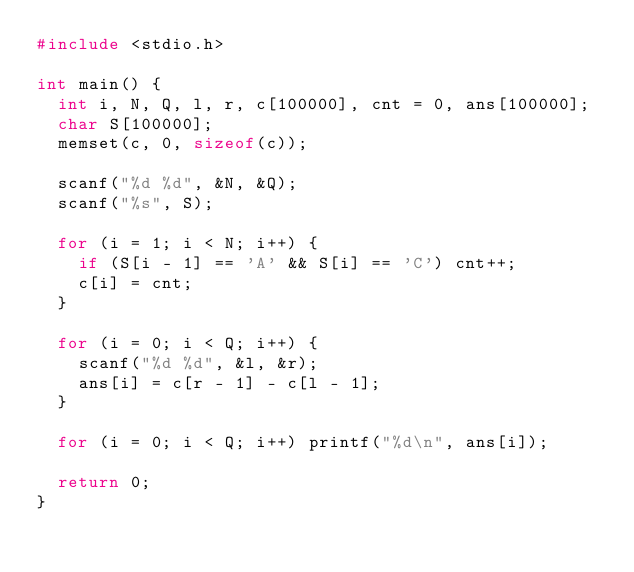Convert code to text. <code><loc_0><loc_0><loc_500><loc_500><_C_>#include <stdio.h>

int main() {
	int i, N, Q, l, r, c[100000], cnt = 0, ans[100000];
	char S[100000];
	memset(c, 0, sizeof(c));

	scanf("%d %d", &N, &Q);
	scanf("%s", S);

	for (i = 1; i < N; i++) {
		if (S[i - 1] == 'A' && S[i] == 'C') cnt++;
		c[i] = cnt;
	}

	for (i = 0; i < Q; i++) {
		scanf("%d %d", &l, &r);
		ans[i] = c[r - 1] - c[l - 1];
	}

	for (i = 0; i < Q; i++) printf("%d\n", ans[i]);

	return 0;
}</code> 